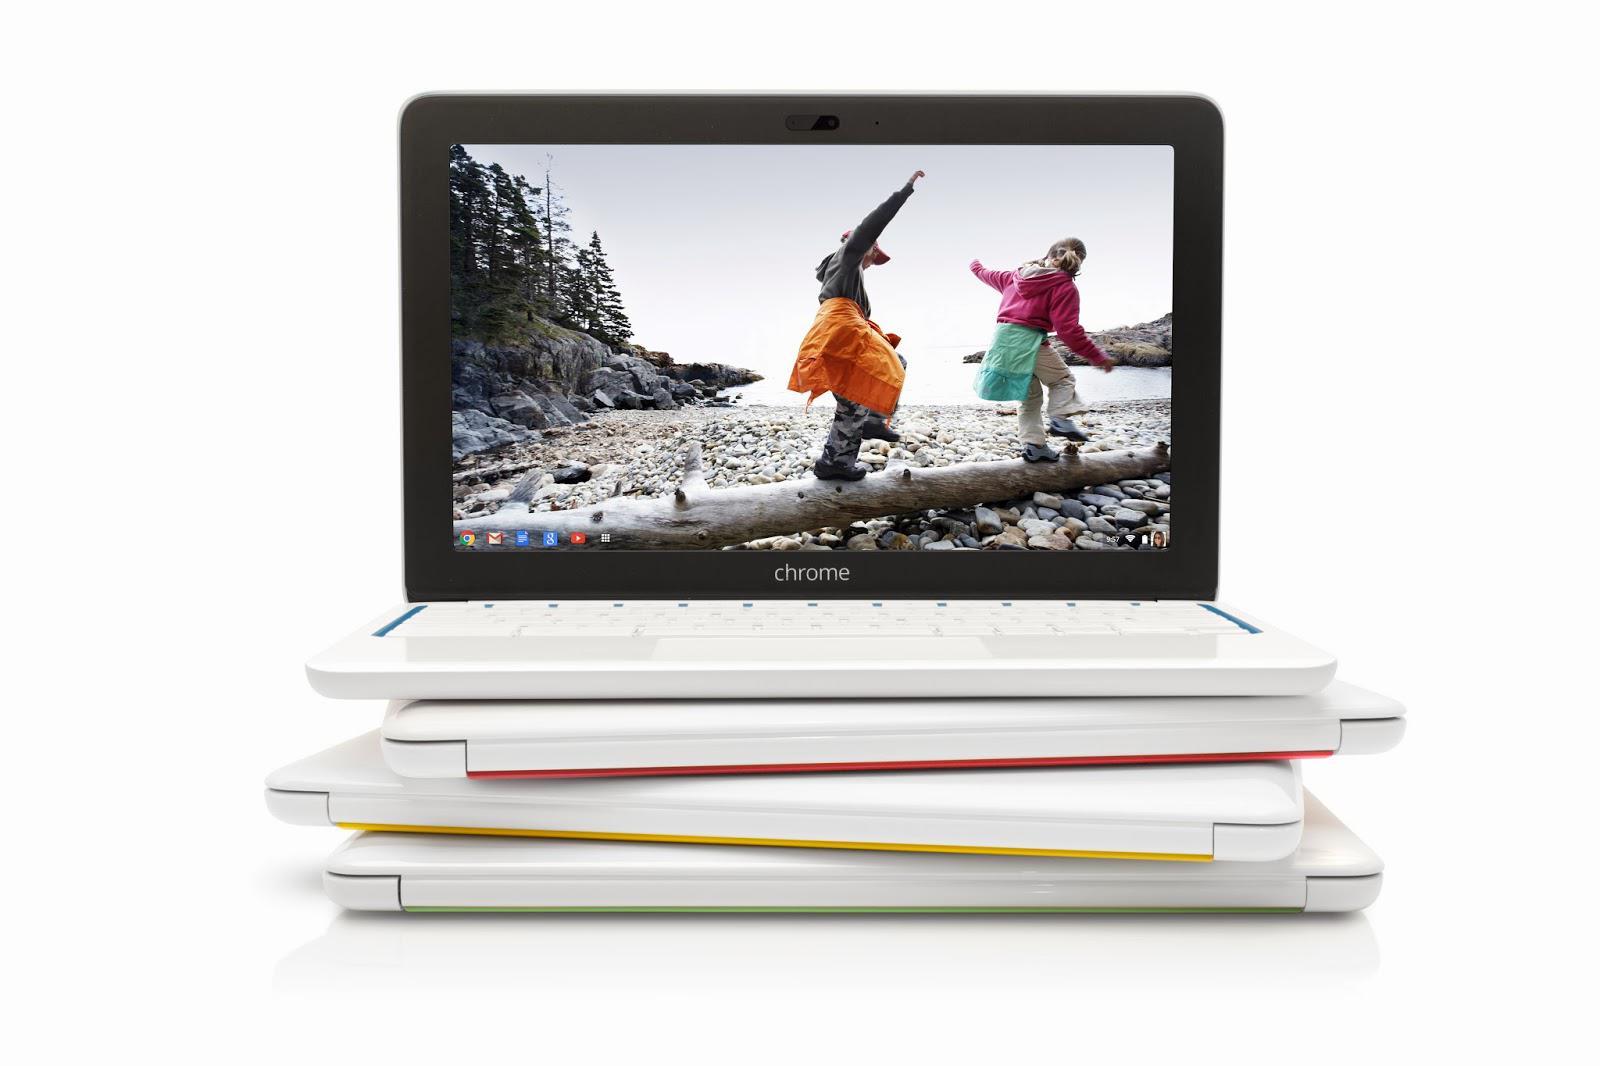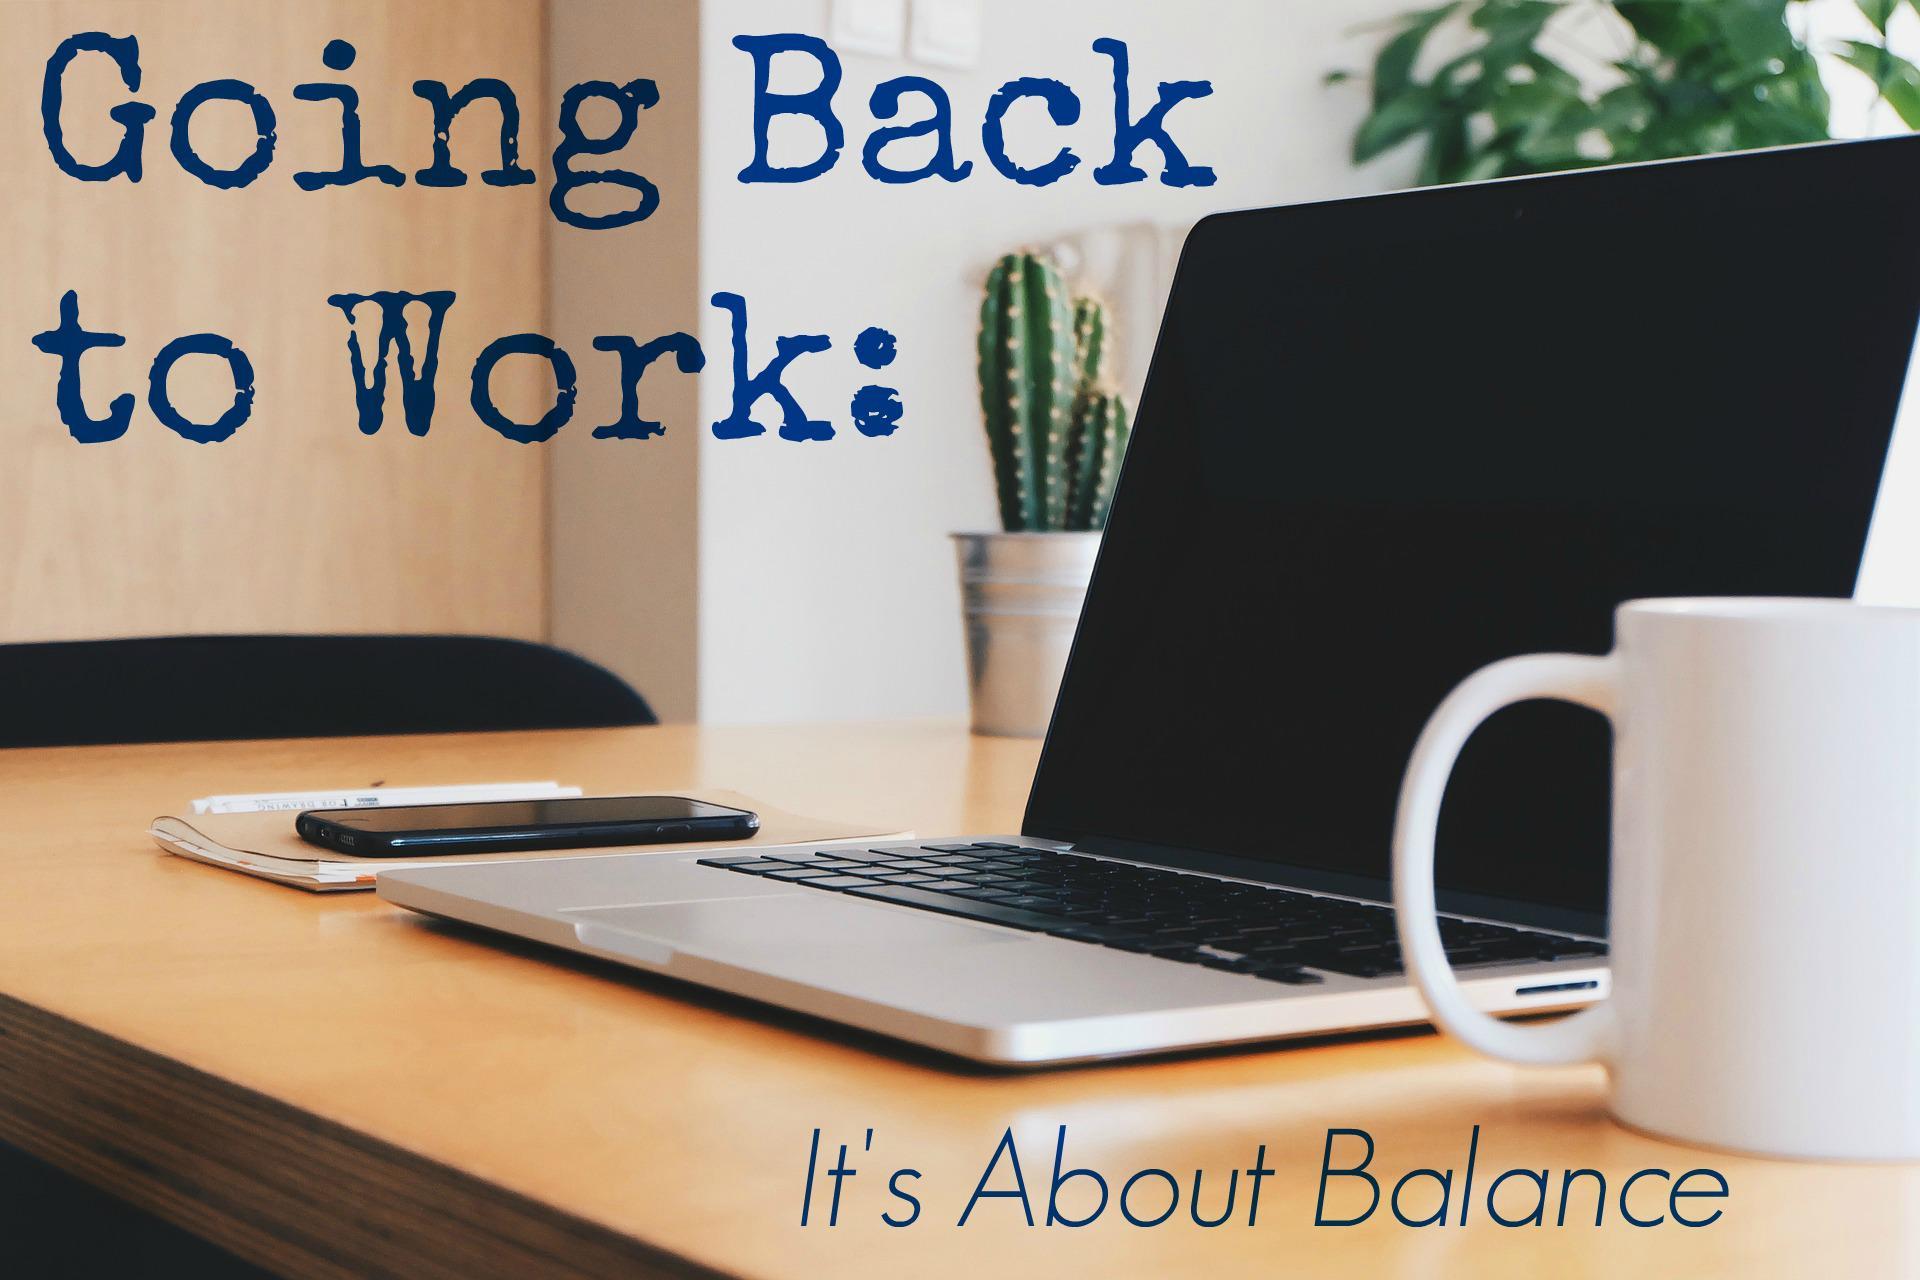The first image is the image on the left, the second image is the image on the right. Analyze the images presented: Is the assertion "A pen is on flat paper by a laptop screen and stacked paper materials in the right image, and the left image includes at least one hand on the base of an open laptop." valid? Answer yes or no. No. The first image is the image on the left, the second image is the image on the right. Evaluate the accuracy of this statement regarding the images: "There is one cup in the right image.". Is it true? Answer yes or no. Yes. 